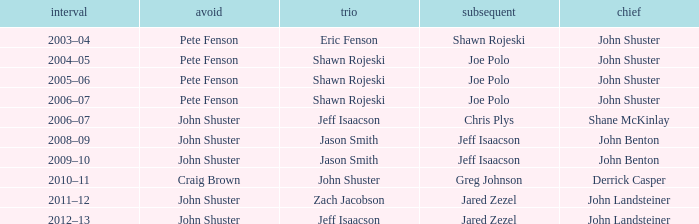Who was the lead with John Shuster as skip in the season of 2009–10? John Benton. 